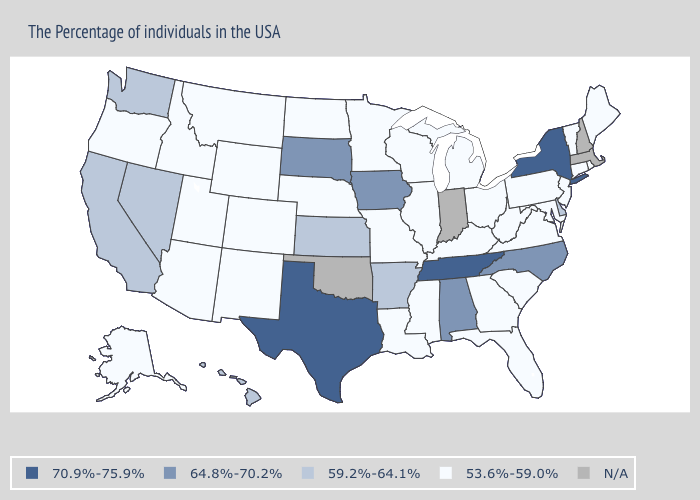Which states hav the highest value in the West?
Concise answer only. Nevada, California, Washington, Hawaii. What is the lowest value in states that border North Dakota?
Write a very short answer. 53.6%-59.0%. What is the value of Wisconsin?
Short answer required. 53.6%-59.0%. What is the value of California?
Keep it brief. 59.2%-64.1%. Is the legend a continuous bar?
Quick response, please. No. Which states have the lowest value in the MidWest?
Concise answer only. Ohio, Michigan, Wisconsin, Illinois, Missouri, Minnesota, Nebraska, North Dakota. What is the value of New York?
Write a very short answer. 70.9%-75.9%. What is the value of Rhode Island?
Short answer required. 53.6%-59.0%. Name the states that have a value in the range N/A?
Be succinct. Massachusetts, New Hampshire, Indiana, Oklahoma. Does the first symbol in the legend represent the smallest category?
Answer briefly. No. What is the value of New Mexico?
Short answer required. 53.6%-59.0%. Does the map have missing data?
Quick response, please. Yes. Does Texas have the highest value in the USA?
Be succinct. Yes. Does Hawaii have the highest value in the West?
Short answer required. Yes. 